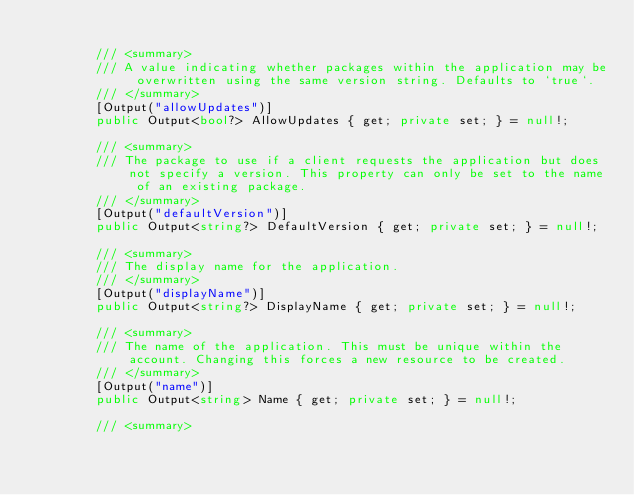<code> <loc_0><loc_0><loc_500><loc_500><_C#_>
        /// <summary>
        /// A value indicating whether packages within the application may be overwritten using the same version string. Defaults to `true`.
        /// </summary>
        [Output("allowUpdates")]
        public Output<bool?> AllowUpdates { get; private set; } = null!;

        /// <summary>
        /// The package to use if a client requests the application but does not specify a version. This property can only be set to the name of an existing package.
        /// </summary>
        [Output("defaultVersion")]
        public Output<string?> DefaultVersion { get; private set; } = null!;

        /// <summary>
        /// The display name for the application.
        /// </summary>
        [Output("displayName")]
        public Output<string?> DisplayName { get; private set; } = null!;

        /// <summary>
        /// The name of the application. This must be unique within the account. Changing this forces a new resource to be created.
        /// </summary>
        [Output("name")]
        public Output<string> Name { get; private set; } = null!;

        /// <summary></code> 